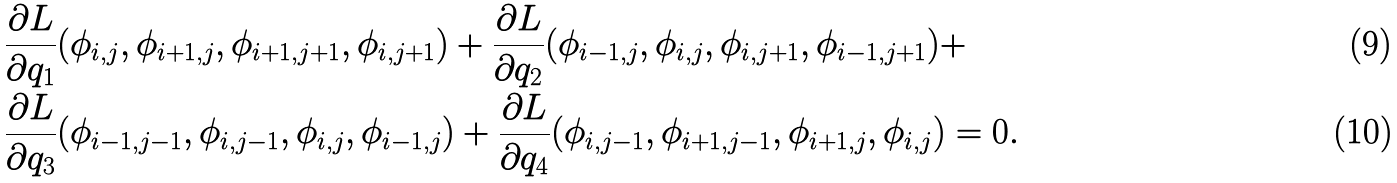<formula> <loc_0><loc_0><loc_500><loc_500>& \frac { \partial L } { \partial q _ { 1 } } ( \phi _ { i , j } , \phi _ { i + 1 , j } , \phi _ { i + 1 , j + 1 } , \phi _ { i , j + 1 } ) + \frac { \partial L } { \partial q _ { 2 } } ( \phi _ { i - 1 , j } , \phi _ { i , j } , \phi _ { i , j + 1 } , \phi _ { i - 1 , j + 1 } ) + \\ & \frac { \partial L } { \partial q _ { 3 } } ( \phi _ { i - 1 , j - 1 } , \phi _ { i , j - 1 } , \phi _ { i , j } , \phi _ { i - 1 , j } ) + \frac { \partial L } { \partial q _ { 4 } } ( \phi _ { i , j - 1 } , \phi _ { i + 1 , j - 1 } , \phi _ { i + 1 , j } , \phi _ { i , j } ) = 0 .</formula> 